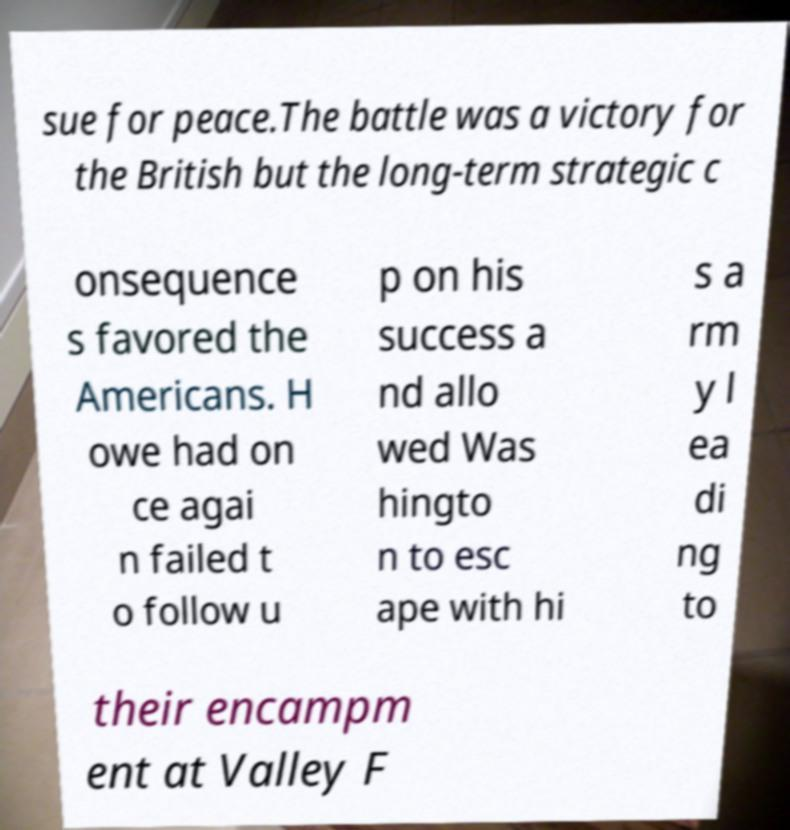Please identify and transcribe the text found in this image. sue for peace.The battle was a victory for the British but the long-term strategic c onsequence s favored the Americans. H owe had on ce agai n failed t o follow u p on his success a nd allo wed Was hingto n to esc ape with hi s a rm y l ea di ng to their encampm ent at Valley F 